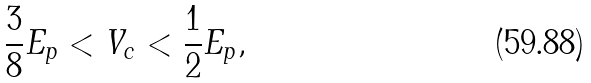<formula> <loc_0><loc_0><loc_500><loc_500>\frac { 3 } { 8 } E _ { p } < V _ { c } < \frac { 1 } { 2 } E _ { p } ,</formula> 